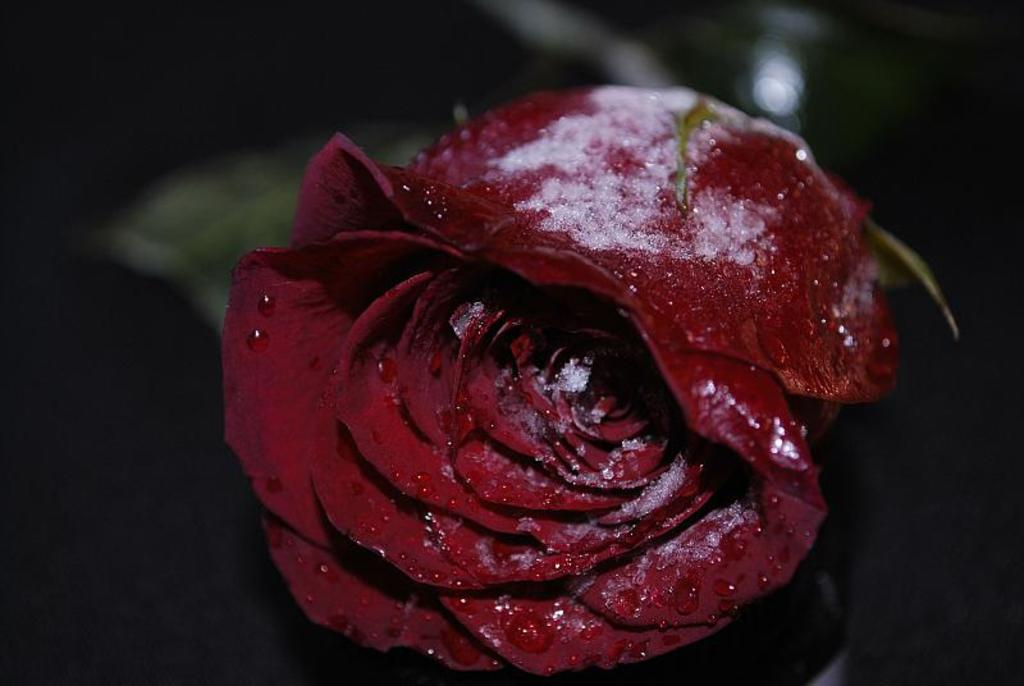What is the main subject of the image? The main subject of the image is a red color rose. Can you describe the position of the rose in the image? The rose is in the middle of the image. What type of authority does the crow have in the image? There is no crow present in the image, so it cannot be determined if it has any authority. 